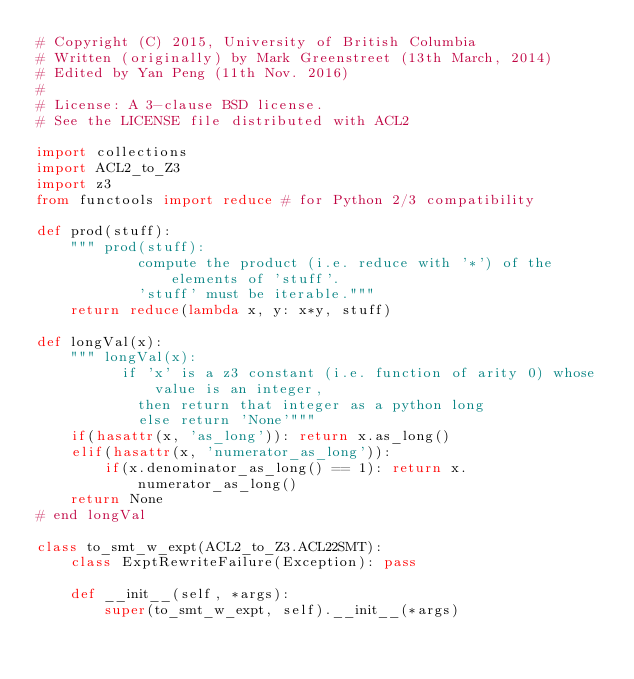Convert code to text. <code><loc_0><loc_0><loc_500><loc_500><_Python_># Copyright (C) 2015, University of British Columbia
# Written (originally) by Mark Greenstreet (13th March, 2014)
# Edited by Yan Peng (11th Nov. 2016)
#
# License: A 3-clause BSD license.
# See the LICENSE file distributed with ACL2

import collections
import ACL2_to_Z3
import z3
from functools import reduce # for Python 2/3 compatibility

def prod(stuff):
    """ prod(stuff):
            compute the product (i.e. reduce with '*') of the elements of 'stuff'.
            'stuff' must be iterable."""
    return reduce(lambda x, y: x*y, stuff)

def longVal(x):
    """ longVal(x):
          if 'x' is a z3 constant (i.e. function of arity 0) whose value is an integer,
            then return that integer as a python long
            else return 'None'"""
    if(hasattr(x, 'as_long')): return x.as_long()
    elif(hasattr(x, 'numerator_as_long')):
        if(x.denominator_as_long() == 1): return x.numerator_as_long()
    return None
# end longVal

class to_smt_w_expt(ACL2_to_Z3.ACL22SMT):
    class ExptRewriteFailure(Exception): pass

    def __init__(self, *args):
        super(to_smt_w_expt, self).__init__(*args)</code> 